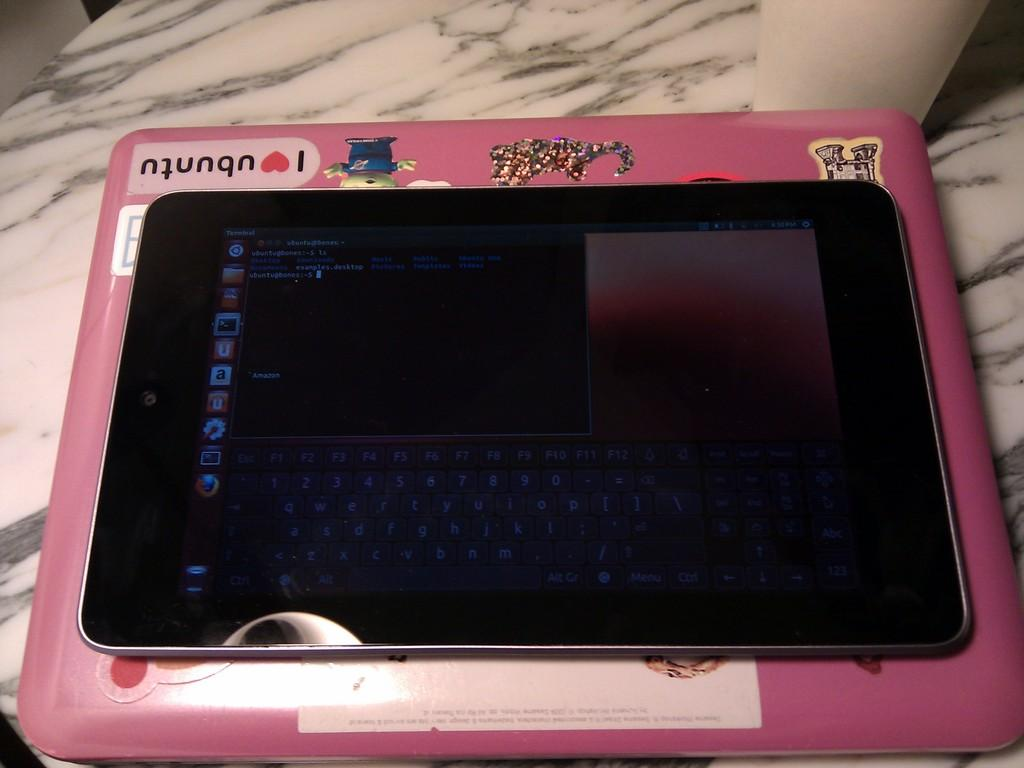What is the main subject of the image? The main subject of the image is a tab. Where is the tab located in the image? The tab is on a table in the image. What can be seen on the tab? There are stickers on the tab in the image. What else is present in the image besides the tab? There is text in the image. Can you tell me how many flowers are in the alley behind the table in the image? There is no alley or flowers present in the image; it only features a tab on a table with text and stickers. 